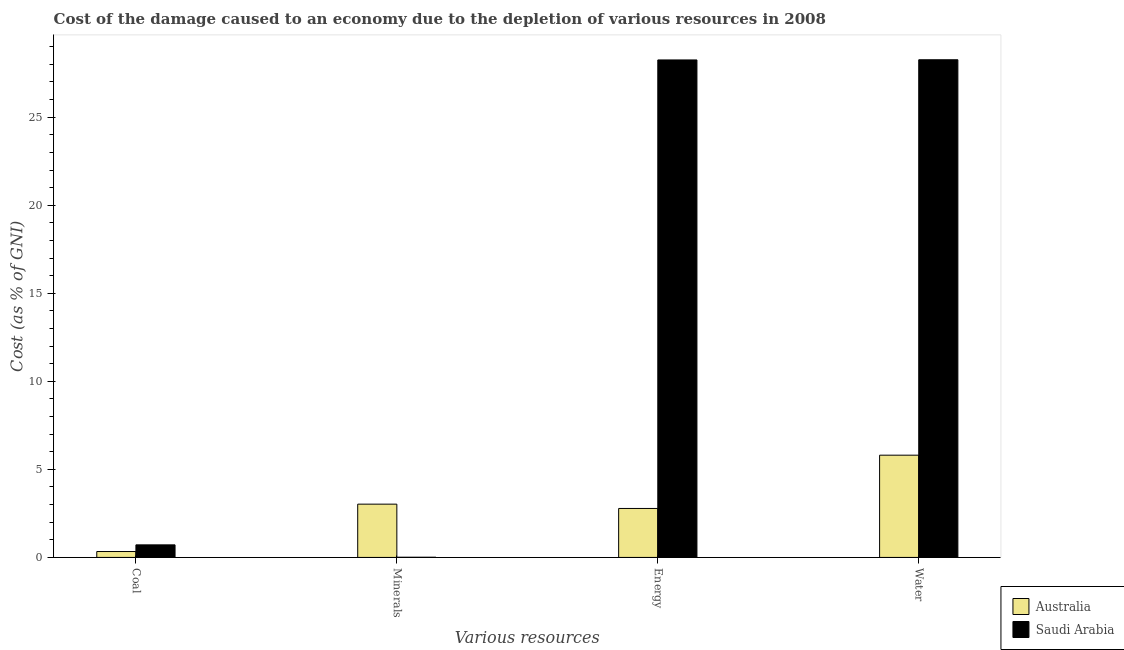What is the label of the 2nd group of bars from the left?
Keep it short and to the point. Minerals. What is the cost of damage due to depletion of energy in Australia?
Your response must be concise. 2.78. Across all countries, what is the maximum cost of damage due to depletion of minerals?
Your answer should be very brief. 3.03. Across all countries, what is the minimum cost of damage due to depletion of energy?
Provide a short and direct response. 2.78. In which country was the cost of damage due to depletion of energy maximum?
Give a very brief answer. Saudi Arabia. What is the total cost of damage due to depletion of energy in the graph?
Offer a very short reply. 31.03. What is the difference between the cost of damage due to depletion of coal in Australia and that in Saudi Arabia?
Give a very brief answer. -0.38. What is the difference between the cost of damage due to depletion of energy in Saudi Arabia and the cost of damage due to depletion of water in Australia?
Offer a terse response. 22.45. What is the average cost of damage due to depletion of minerals per country?
Provide a succinct answer. 1.52. What is the difference between the cost of damage due to depletion of coal and cost of damage due to depletion of minerals in Saudi Arabia?
Offer a terse response. 0.7. In how many countries, is the cost of damage due to depletion of coal greater than 22 %?
Provide a short and direct response. 0. What is the ratio of the cost of damage due to depletion of coal in Saudi Arabia to that in Australia?
Your answer should be very brief. 2.13. What is the difference between the highest and the second highest cost of damage due to depletion of energy?
Provide a short and direct response. 25.47. What is the difference between the highest and the lowest cost of damage due to depletion of minerals?
Make the answer very short. 3.02. In how many countries, is the cost of damage due to depletion of minerals greater than the average cost of damage due to depletion of minerals taken over all countries?
Offer a terse response. 1. Is the sum of the cost of damage due to depletion of water in Australia and Saudi Arabia greater than the maximum cost of damage due to depletion of minerals across all countries?
Provide a succinct answer. Yes. Is it the case that in every country, the sum of the cost of damage due to depletion of water and cost of damage due to depletion of coal is greater than the sum of cost of damage due to depletion of energy and cost of damage due to depletion of minerals?
Offer a terse response. No. What does the 2nd bar from the left in Minerals represents?
Offer a terse response. Saudi Arabia. What does the 1st bar from the right in Water represents?
Give a very brief answer. Saudi Arabia. How many bars are there?
Provide a succinct answer. 8. Are all the bars in the graph horizontal?
Make the answer very short. No. How many countries are there in the graph?
Your answer should be very brief. 2. Does the graph contain any zero values?
Keep it short and to the point. No. Does the graph contain grids?
Make the answer very short. No. How many legend labels are there?
Provide a short and direct response. 2. What is the title of the graph?
Ensure brevity in your answer.  Cost of the damage caused to an economy due to the depletion of various resources in 2008 . Does "Finland" appear as one of the legend labels in the graph?
Make the answer very short. No. What is the label or title of the X-axis?
Your response must be concise. Various resources. What is the label or title of the Y-axis?
Your answer should be very brief. Cost (as % of GNI). What is the Cost (as % of GNI) in Australia in Coal?
Your answer should be compact. 0.34. What is the Cost (as % of GNI) of Saudi Arabia in Coal?
Offer a very short reply. 0.71. What is the Cost (as % of GNI) in Australia in Minerals?
Provide a short and direct response. 3.03. What is the Cost (as % of GNI) in Saudi Arabia in Minerals?
Give a very brief answer. 0.01. What is the Cost (as % of GNI) of Australia in Energy?
Give a very brief answer. 2.78. What is the Cost (as % of GNI) of Saudi Arabia in Energy?
Your response must be concise. 28.25. What is the Cost (as % of GNI) in Australia in Water?
Provide a short and direct response. 5.81. What is the Cost (as % of GNI) of Saudi Arabia in Water?
Offer a very short reply. 28.26. Across all Various resources, what is the maximum Cost (as % of GNI) of Australia?
Make the answer very short. 5.81. Across all Various resources, what is the maximum Cost (as % of GNI) of Saudi Arabia?
Your answer should be very brief. 28.26. Across all Various resources, what is the minimum Cost (as % of GNI) in Australia?
Make the answer very short. 0.34. Across all Various resources, what is the minimum Cost (as % of GNI) in Saudi Arabia?
Provide a succinct answer. 0.01. What is the total Cost (as % of GNI) in Australia in the graph?
Your answer should be compact. 11.95. What is the total Cost (as % of GNI) of Saudi Arabia in the graph?
Your response must be concise. 57.24. What is the difference between the Cost (as % of GNI) in Australia in Coal and that in Minerals?
Provide a short and direct response. -2.69. What is the difference between the Cost (as % of GNI) in Saudi Arabia in Coal and that in Minerals?
Offer a terse response. 0.7. What is the difference between the Cost (as % of GNI) of Australia in Coal and that in Energy?
Your answer should be compact. -2.44. What is the difference between the Cost (as % of GNI) in Saudi Arabia in Coal and that in Energy?
Your answer should be compact. -27.54. What is the difference between the Cost (as % of GNI) of Australia in Coal and that in Water?
Offer a terse response. -5.47. What is the difference between the Cost (as % of GNI) of Saudi Arabia in Coal and that in Water?
Your answer should be very brief. -27.55. What is the difference between the Cost (as % of GNI) in Australia in Minerals and that in Energy?
Ensure brevity in your answer.  0.25. What is the difference between the Cost (as % of GNI) in Saudi Arabia in Minerals and that in Energy?
Ensure brevity in your answer.  -28.24. What is the difference between the Cost (as % of GNI) of Australia in Minerals and that in Water?
Ensure brevity in your answer.  -2.78. What is the difference between the Cost (as % of GNI) of Saudi Arabia in Minerals and that in Water?
Your answer should be very brief. -28.25. What is the difference between the Cost (as % of GNI) in Australia in Energy and that in Water?
Your response must be concise. -3.03. What is the difference between the Cost (as % of GNI) of Saudi Arabia in Energy and that in Water?
Make the answer very short. -0.01. What is the difference between the Cost (as % of GNI) of Australia in Coal and the Cost (as % of GNI) of Saudi Arabia in Minerals?
Your answer should be very brief. 0.32. What is the difference between the Cost (as % of GNI) of Australia in Coal and the Cost (as % of GNI) of Saudi Arabia in Energy?
Give a very brief answer. -27.92. What is the difference between the Cost (as % of GNI) in Australia in Coal and the Cost (as % of GNI) in Saudi Arabia in Water?
Give a very brief answer. -27.93. What is the difference between the Cost (as % of GNI) in Australia in Minerals and the Cost (as % of GNI) in Saudi Arabia in Energy?
Provide a succinct answer. -25.23. What is the difference between the Cost (as % of GNI) of Australia in Minerals and the Cost (as % of GNI) of Saudi Arabia in Water?
Keep it short and to the point. -25.24. What is the difference between the Cost (as % of GNI) of Australia in Energy and the Cost (as % of GNI) of Saudi Arabia in Water?
Keep it short and to the point. -25.48. What is the average Cost (as % of GNI) in Australia per Various resources?
Your answer should be very brief. 2.99. What is the average Cost (as % of GNI) in Saudi Arabia per Various resources?
Make the answer very short. 14.31. What is the difference between the Cost (as % of GNI) of Australia and Cost (as % of GNI) of Saudi Arabia in Coal?
Offer a very short reply. -0.38. What is the difference between the Cost (as % of GNI) of Australia and Cost (as % of GNI) of Saudi Arabia in Minerals?
Give a very brief answer. 3.02. What is the difference between the Cost (as % of GNI) in Australia and Cost (as % of GNI) in Saudi Arabia in Energy?
Offer a terse response. -25.47. What is the difference between the Cost (as % of GNI) of Australia and Cost (as % of GNI) of Saudi Arabia in Water?
Your answer should be compact. -22.46. What is the ratio of the Cost (as % of GNI) in Australia in Coal to that in Minerals?
Offer a terse response. 0.11. What is the ratio of the Cost (as % of GNI) in Saudi Arabia in Coal to that in Minerals?
Ensure brevity in your answer.  67.56. What is the ratio of the Cost (as % of GNI) in Australia in Coal to that in Energy?
Give a very brief answer. 0.12. What is the ratio of the Cost (as % of GNI) of Saudi Arabia in Coal to that in Energy?
Offer a very short reply. 0.03. What is the ratio of the Cost (as % of GNI) in Australia in Coal to that in Water?
Make the answer very short. 0.06. What is the ratio of the Cost (as % of GNI) in Saudi Arabia in Coal to that in Water?
Your answer should be very brief. 0.03. What is the ratio of the Cost (as % of GNI) of Australia in Minerals to that in Energy?
Make the answer very short. 1.09. What is the ratio of the Cost (as % of GNI) of Australia in Minerals to that in Water?
Provide a short and direct response. 0.52. What is the ratio of the Cost (as % of GNI) of Saudi Arabia in Minerals to that in Water?
Your answer should be compact. 0. What is the ratio of the Cost (as % of GNI) of Australia in Energy to that in Water?
Give a very brief answer. 0.48. What is the ratio of the Cost (as % of GNI) of Saudi Arabia in Energy to that in Water?
Provide a succinct answer. 1. What is the difference between the highest and the second highest Cost (as % of GNI) in Australia?
Offer a very short reply. 2.78. What is the difference between the highest and the second highest Cost (as % of GNI) of Saudi Arabia?
Give a very brief answer. 0.01. What is the difference between the highest and the lowest Cost (as % of GNI) of Australia?
Offer a very short reply. 5.47. What is the difference between the highest and the lowest Cost (as % of GNI) of Saudi Arabia?
Ensure brevity in your answer.  28.25. 